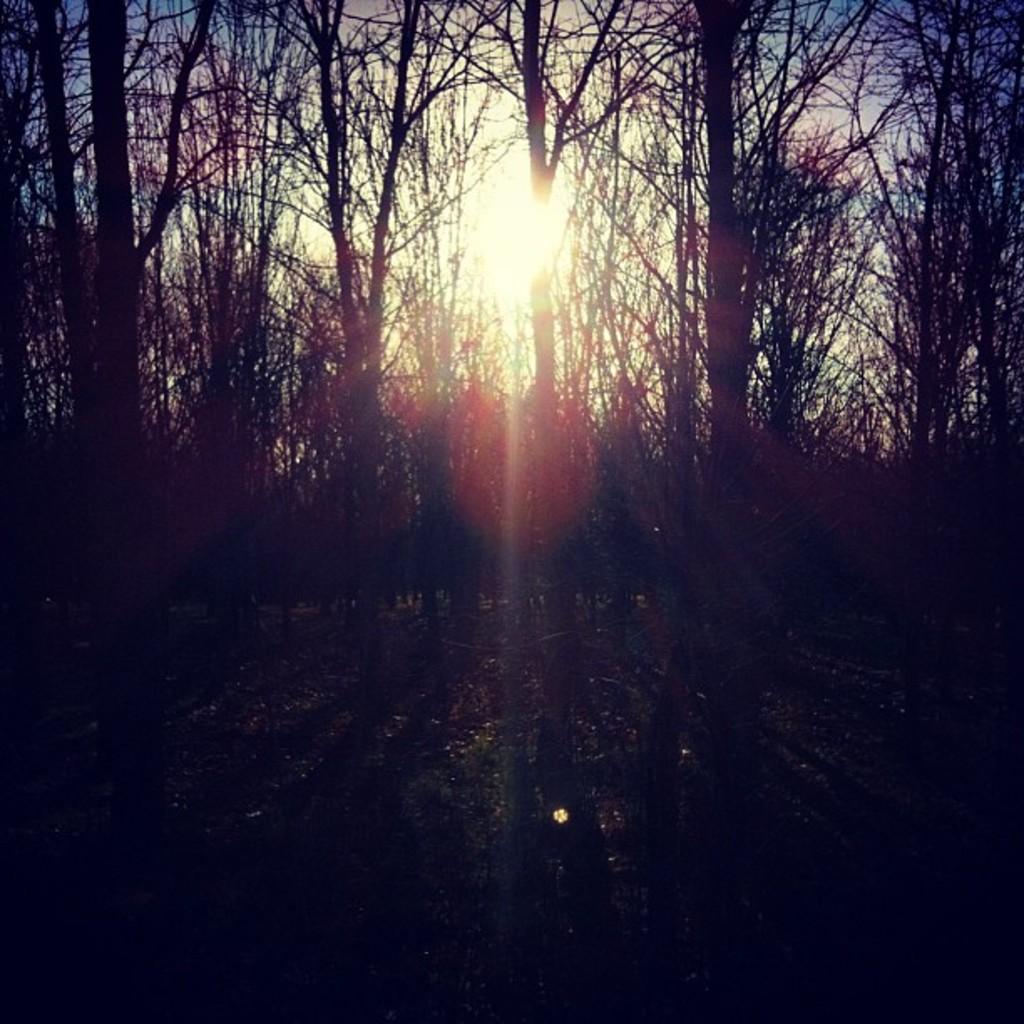How would you summarize this image in a sentence or two? In this image we can see trees. In the background there is a sky. 